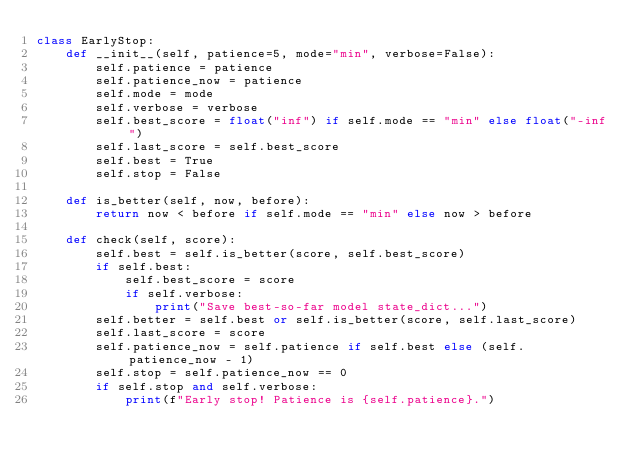Convert code to text. <code><loc_0><loc_0><loc_500><loc_500><_Python_>class EarlyStop:
    def __init__(self, patience=5, mode="min", verbose=False):
        self.patience = patience
        self.patience_now = patience
        self.mode = mode
        self.verbose = verbose
        self.best_score = float("inf") if self.mode == "min" else float("-inf")
        self.last_score = self.best_score
        self.best = True
        self.stop = False

    def is_better(self, now, before):
        return now < before if self.mode == "min" else now > before

    def check(self, score):
        self.best = self.is_better(score, self.best_score)
        if self.best:
            self.best_score = score
            if self.verbose:
                print("Save best-so-far model state_dict...")
        self.better = self.best or self.is_better(score, self.last_score)
        self.last_score = score
        self.patience_now = self.patience if self.best else (self.patience_now - 1)
        self.stop = self.patience_now == 0
        if self.stop and self.verbose:
            print(f"Early stop! Patience is {self.patience}.")
</code> 